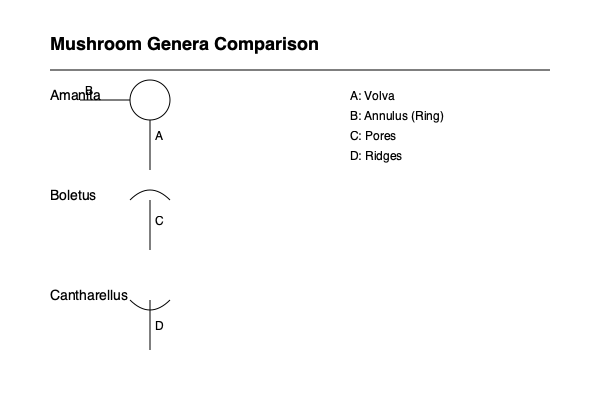Based on the labeled diagram, which morphological feature is unique to the Amanita genus and is crucial for its identification? To answer this question, let's analyze the morphological features shown for each mushroom genus in the diagram:

1. Amanita:
   - Shows a circular structure at the base (A), which is the volva.
   - Has a ring-like structure on the stem (B), which is the annulus.

2. Boletus:
   - Displays a convex cap.
   - Shows pores (C) underneath the cap instead of gills.

3. Cantharellus:
   - Has a concave cap.
   - Shows ridges (D) underneath the cap instead of gills.

Among these features, the volva (A) is unique to the Amanita genus. The volva is a cup-like structure at the base of the stem, which is a remnant of the universal veil that covered the entire mushroom in its early growth stages.

While the annulus (ring) is also present in Amanita, it's not unique to this genus as it can be found in other mushroom genera as well.

The pores in Boletus and ridges in Cantharellus are characteristic features of their respective genera but are not present in Amanita.

Therefore, the volva is the unique and crucial morphological feature for identifying the Amanita genus.
Answer: Volva 